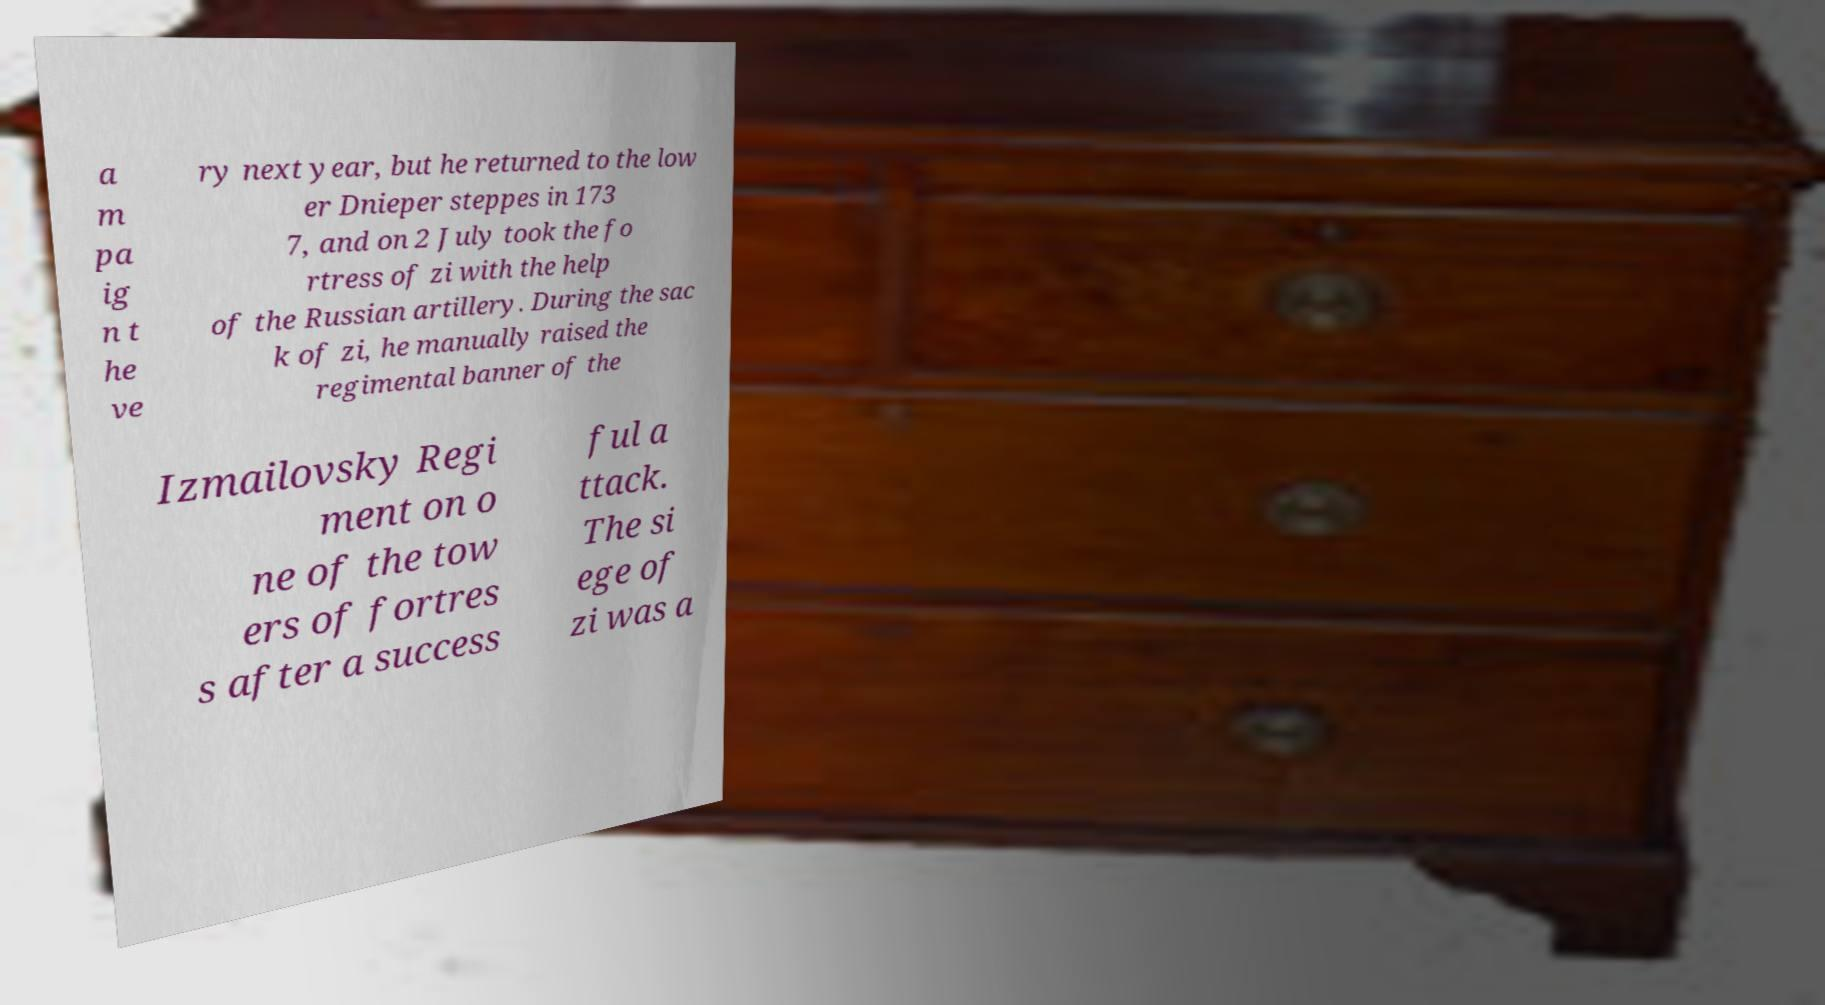I need the written content from this picture converted into text. Can you do that? a m pa ig n t he ve ry next year, but he returned to the low er Dnieper steppes in 173 7, and on 2 July took the fo rtress of zi with the help of the Russian artillery. During the sac k of zi, he manually raised the regimental banner of the Izmailovsky Regi ment on o ne of the tow ers of fortres s after a success ful a ttack. The si ege of zi was a 